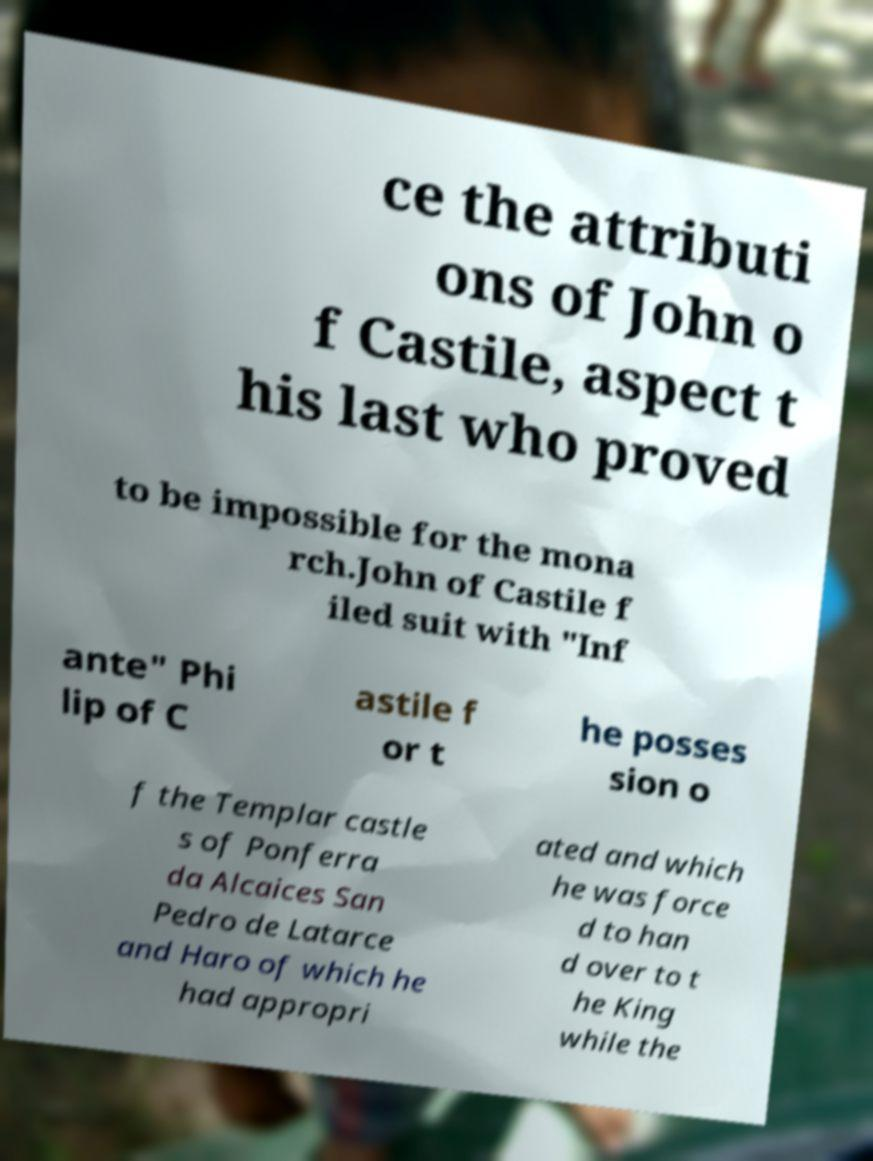Can you accurately transcribe the text from the provided image for me? ce the attributi ons of John o f Castile, aspect t his last who proved to be impossible for the mona rch.John of Castile f iled suit with "Inf ante" Phi lip of C astile f or t he posses sion o f the Templar castle s of Ponferra da Alcaices San Pedro de Latarce and Haro of which he had appropri ated and which he was force d to han d over to t he King while the 